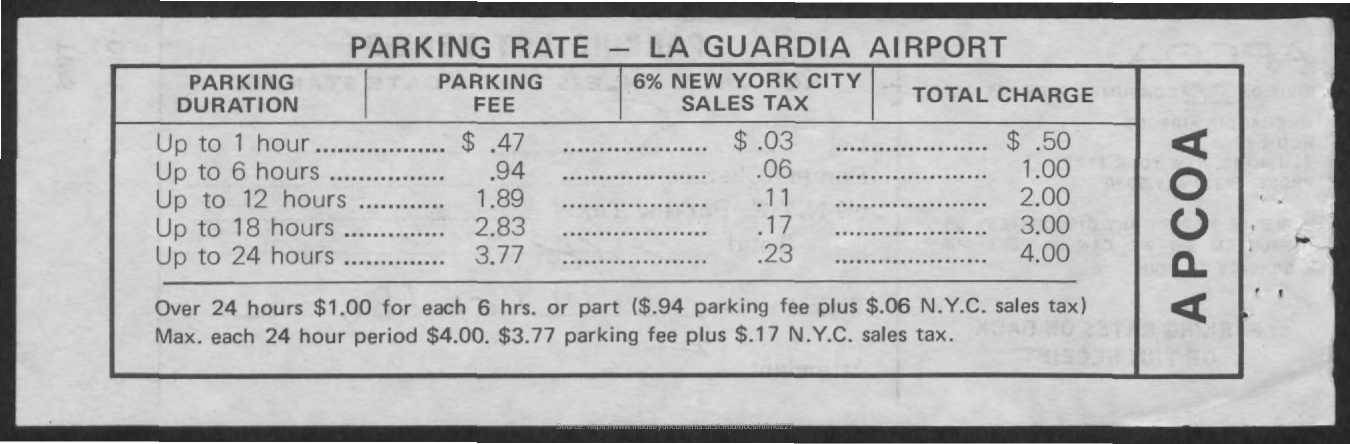Total charges for parking up to 1 hour?
Your response must be concise. $.50. What is total charge for parking without sales tax up to 24 hours?
Your answer should be compact. $3.77. 